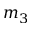<formula> <loc_0><loc_0><loc_500><loc_500>m _ { 3 }</formula> 